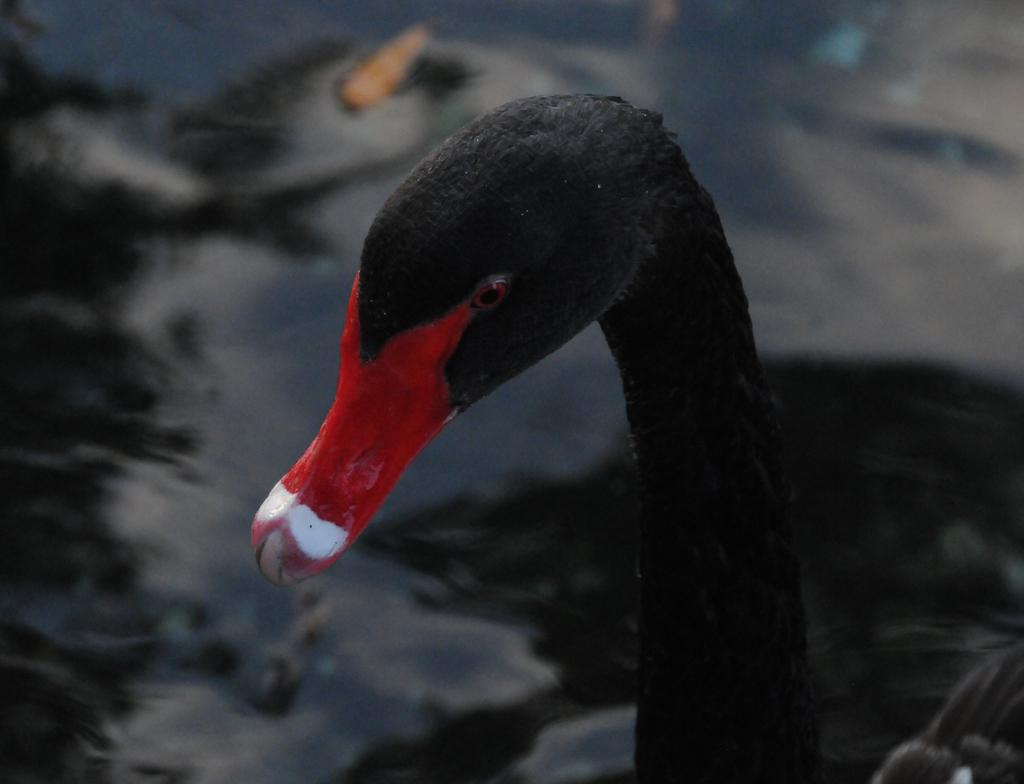What is the main subject of the image? There is a bird in the middle of the image. What can be seen in the background of the image? There is water visible in the background of the image. What is the color of the water in the image? The water appears to be black in color. What type of guitar can be seen being played by the bird in the image? There is no guitar present in the image; it features a bird and black water in the background. 